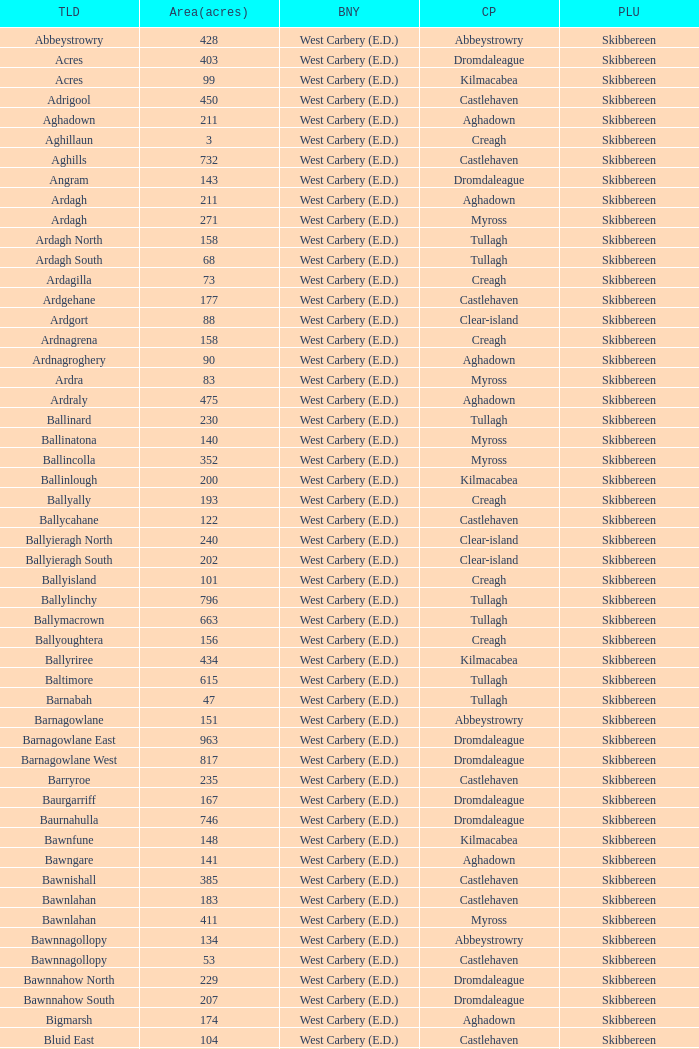What are the Baronies when the area (in acres) is 276? West Carbery (E.D.). 